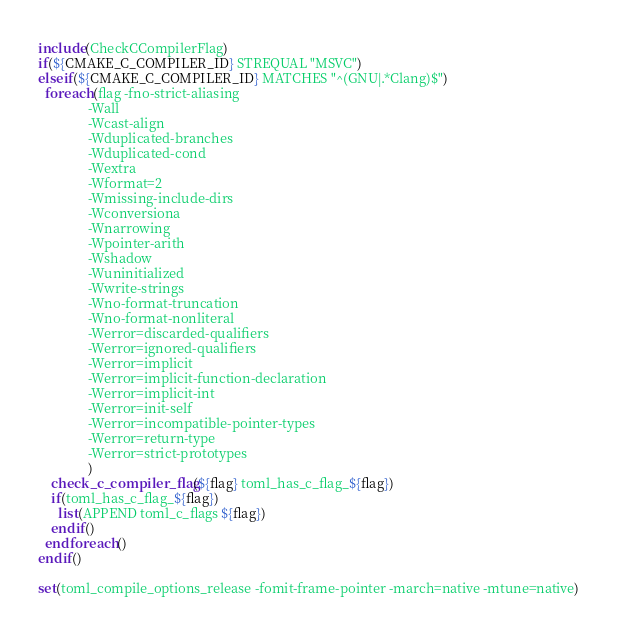<code> <loc_0><loc_0><loc_500><loc_500><_CMake_>include(CheckCCompilerFlag)
if(${CMAKE_C_COMPILER_ID} STREQUAL "MSVC")
elseif(${CMAKE_C_COMPILER_ID} MATCHES "^(GNU|.*Clang)$")
  foreach(flag -fno-strict-aliasing
               -Wall
               -Wcast-align
               -Wduplicated-branches
               -Wduplicated-cond
               -Wextra
               -Wformat=2
               -Wmissing-include-dirs
               -Wconversiona
               -Wnarrowing
               -Wpointer-arith
               -Wshadow
               -Wuninitialized
               -Wwrite-strings
               -Wno-format-truncation
               -Wno-format-nonliteral
               -Werror=discarded-qualifiers
               -Werror=ignored-qualifiers
               -Werror=implicit
               -Werror=implicit-function-declaration
               -Werror=implicit-int
               -Werror=init-self
               -Werror=incompatible-pointer-types
               -Werror=return-type
               -Werror=strict-prototypes
               )
    check_c_compiler_flag(${flag} toml_has_c_flag_${flag})
    if(toml_has_c_flag_${flag})
      list(APPEND toml_c_flags ${flag})
    endif()
  endforeach()
endif()

set(toml_compile_options_release -fomit-frame-pointer -march=native -mtune=native)
</code> 